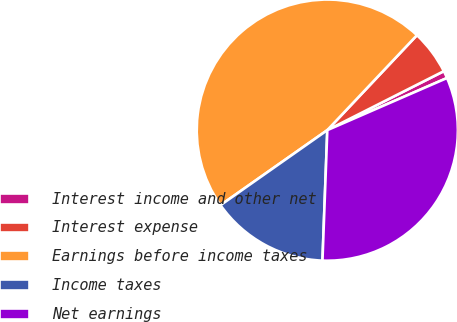Convert chart. <chart><loc_0><loc_0><loc_500><loc_500><pie_chart><fcel>Interest income and other net<fcel>Interest expense<fcel>Earnings before income taxes<fcel>Income taxes<fcel>Net earnings<nl><fcel>0.92%<fcel>5.5%<fcel>46.79%<fcel>14.66%<fcel>32.13%<nl></chart> 